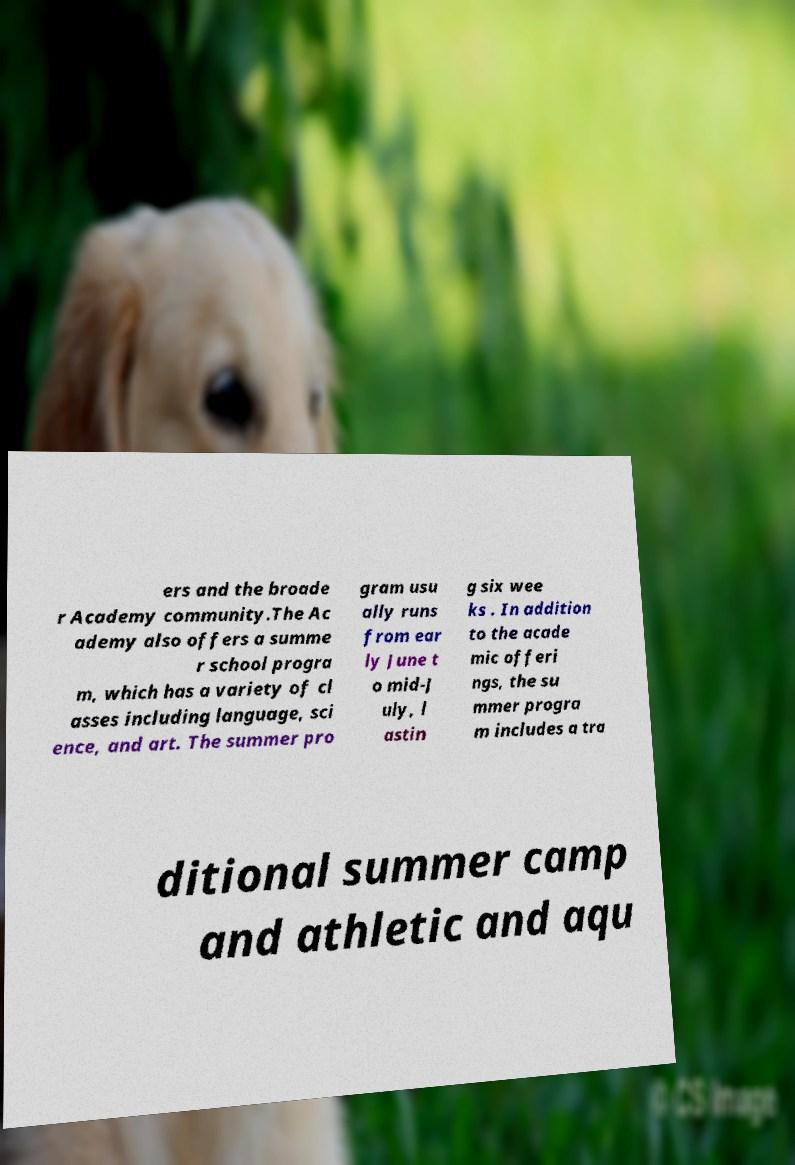Could you extract and type out the text from this image? ers and the broade r Academy community.The Ac ademy also offers a summe r school progra m, which has a variety of cl asses including language, sci ence, and art. The summer pro gram usu ally runs from ear ly June t o mid-J uly, l astin g six wee ks . In addition to the acade mic offeri ngs, the su mmer progra m includes a tra ditional summer camp and athletic and aqu 